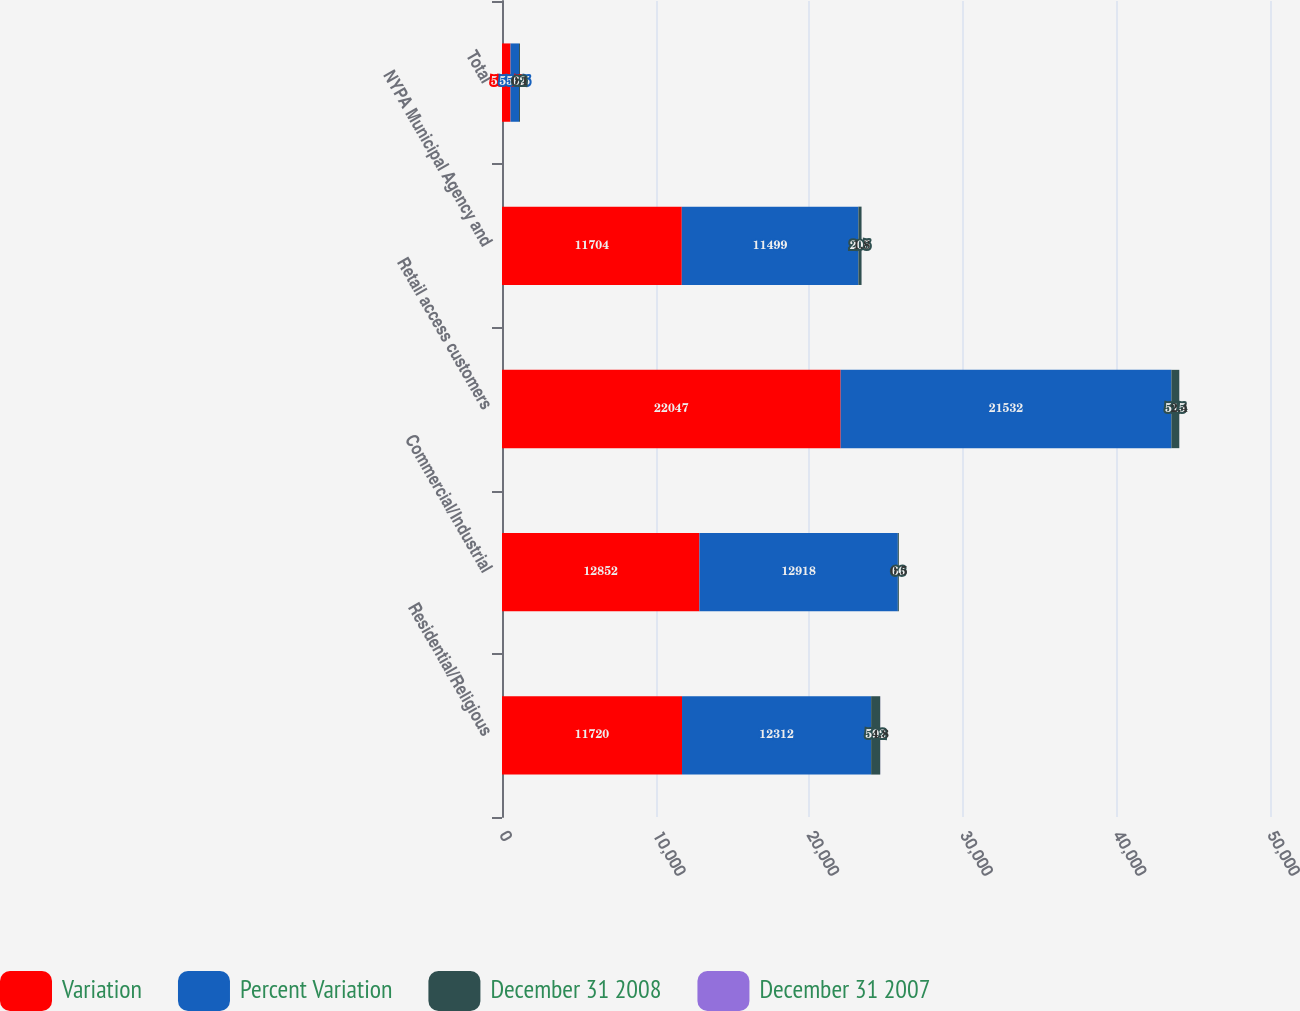Convert chart to OTSL. <chart><loc_0><loc_0><loc_500><loc_500><stacked_bar_chart><ecel><fcel>Residential/Religious<fcel>Commercial/Industrial<fcel>Retail access customers<fcel>NYPA Municipal Agency and<fcel>Total<nl><fcel>Variation<fcel>11720<fcel>12852<fcel>22047<fcel>11704<fcel>553.5<nl><fcel>Percent Variation<fcel>12312<fcel>12918<fcel>21532<fcel>11499<fcel>553.5<nl><fcel>December 31 2008<fcel>592<fcel>66<fcel>515<fcel>205<fcel>62<nl><fcel>December 31 2007<fcel>4.8<fcel>0.5<fcel>2.4<fcel>1.8<fcel>0.1<nl></chart> 